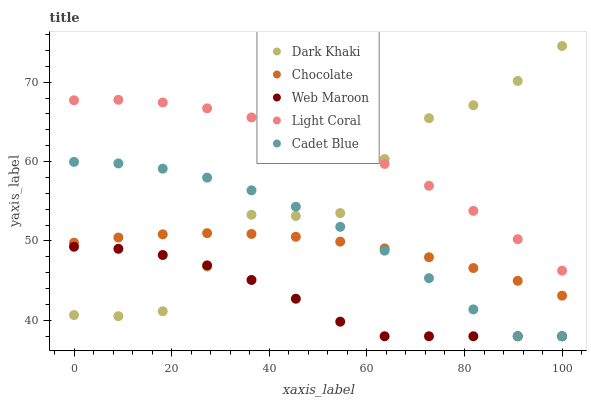Does Web Maroon have the minimum area under the curve?
Answer yes or no. Yes. Does Light Coral have the maximum area under the curve?
Answer yes or no. Yes. Does Cadet Blue have the minimum area under the curve?
Answer yes or no. No. Does Cadet Blue have the maximum area under the curve?
Answer yes or no. No. Is Chocolate the smoothest?
Answer yes or no. Yes. Is Dark Khaki the roughest?
Answer yes or no. Yes. Is Light Coral the smoothest?
Answer yes or no. No. Is Light Coral the roughest?
Answer yes or no. No. Does Cadet Blue have the lowest value?
Answer yes or no. Yes. Does Light Coral have the lowest value?
Answer yes or no. No. Does Dark Khaki have the highest value?
Answer yes or no. Yes. Does Light Coral have the highest value?
Answer yes or no. No. Is Web Maroon less than Light Coral?
Answer yes or no. Yes. Is Light Coral greater than Chocolate?
Answer yes or no. Yes. Does Cadet Blue intersect Web Maroon?
Answer yes or no. Yes. Is Cadet Blue less than Web Maroon?
Answer yes or no. No. Is Cadet Blue greater than Web Maroon?
Answer yes or no. No. Does Web Maroon intersect Light Coral?
Answer yes or no. No. 